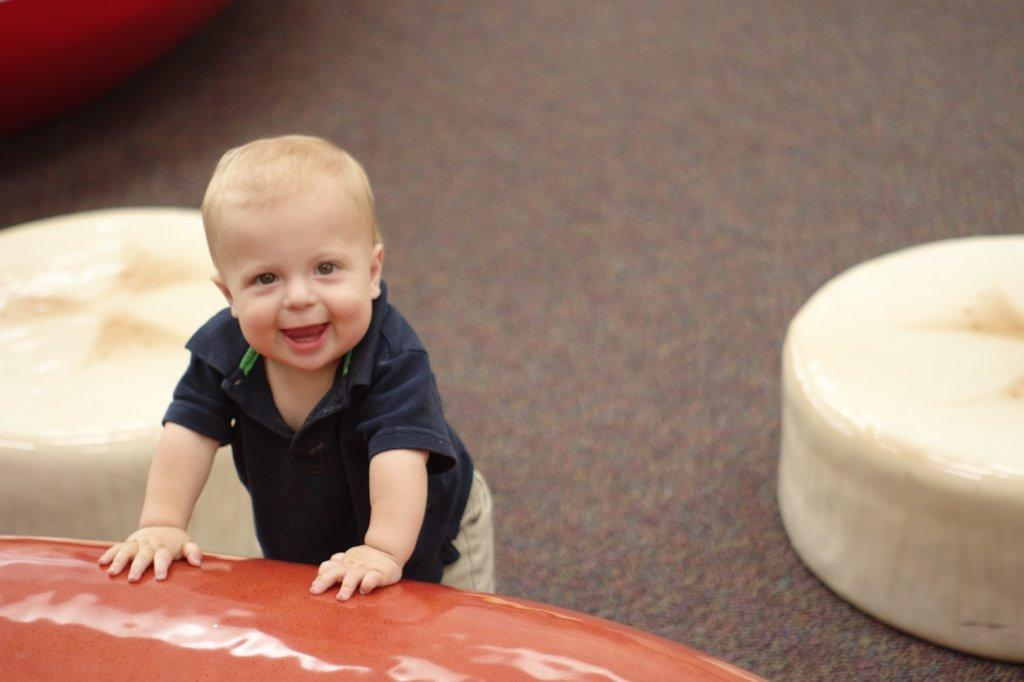What is the main subject of the image? The main subject of the image is a kid. What is the kid doing in the image? The kid is smiling in the image. Is the kid interacting with any object in the image? Yes, the kid is leaning on an object in the image. What type of song is the kid singing in the image? There is no indication in the image that the kid is singing a song, so it cannot be determined from the picture. 